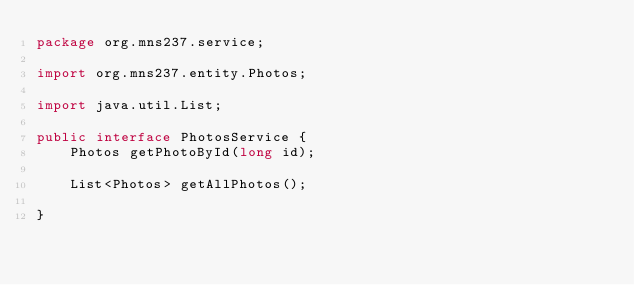Convert code to text. <code><loc_0><loc_0><loc_500><loc_500><_Java_>package org.mns237.service;

import org.mns237.entity.Photos;

import java.util.List;

public interface PhotosService {
    Photos getPhotoById(long id);

    List<Photos> getAllPhotos();

}
</code> 